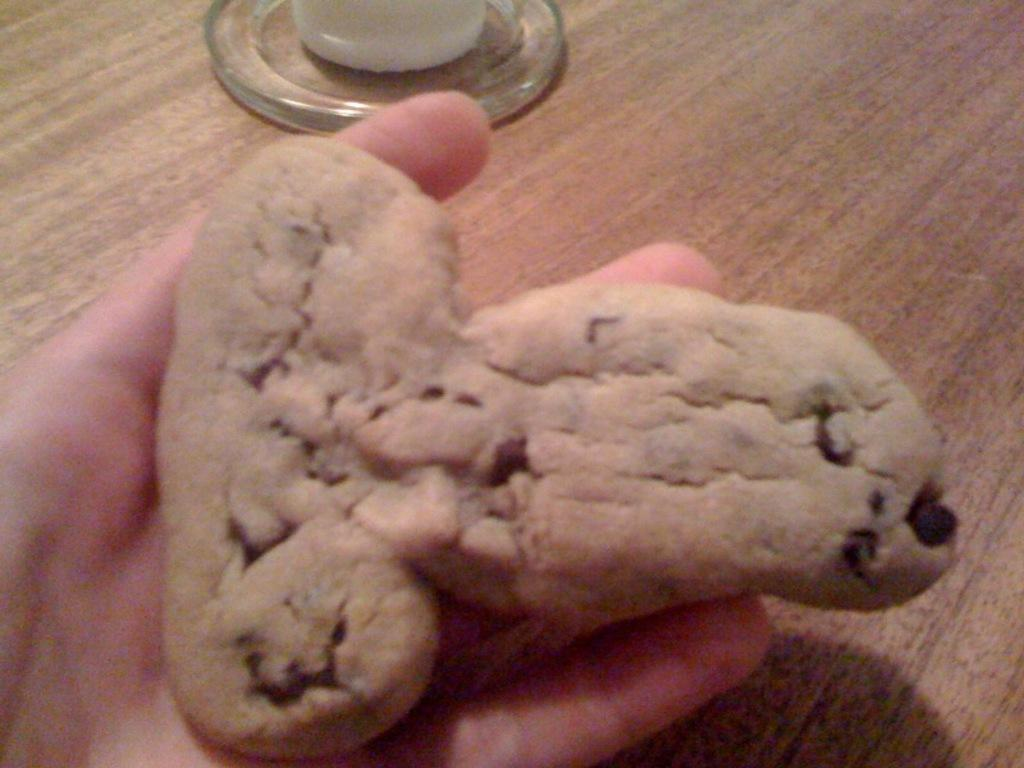What is the person holding in their hand in the image? There is an object in the person's hand in the image. What can be seen on a surface in the image? There is a glass object on a surface in the image. What is the color of the surface the glass object is on? The surface is brown in color. What musical instrument is the person playing in the image? There is no musical instrument visible in the image. What type of property is shown in the background of the image? There is no property shown in the background of the image. 